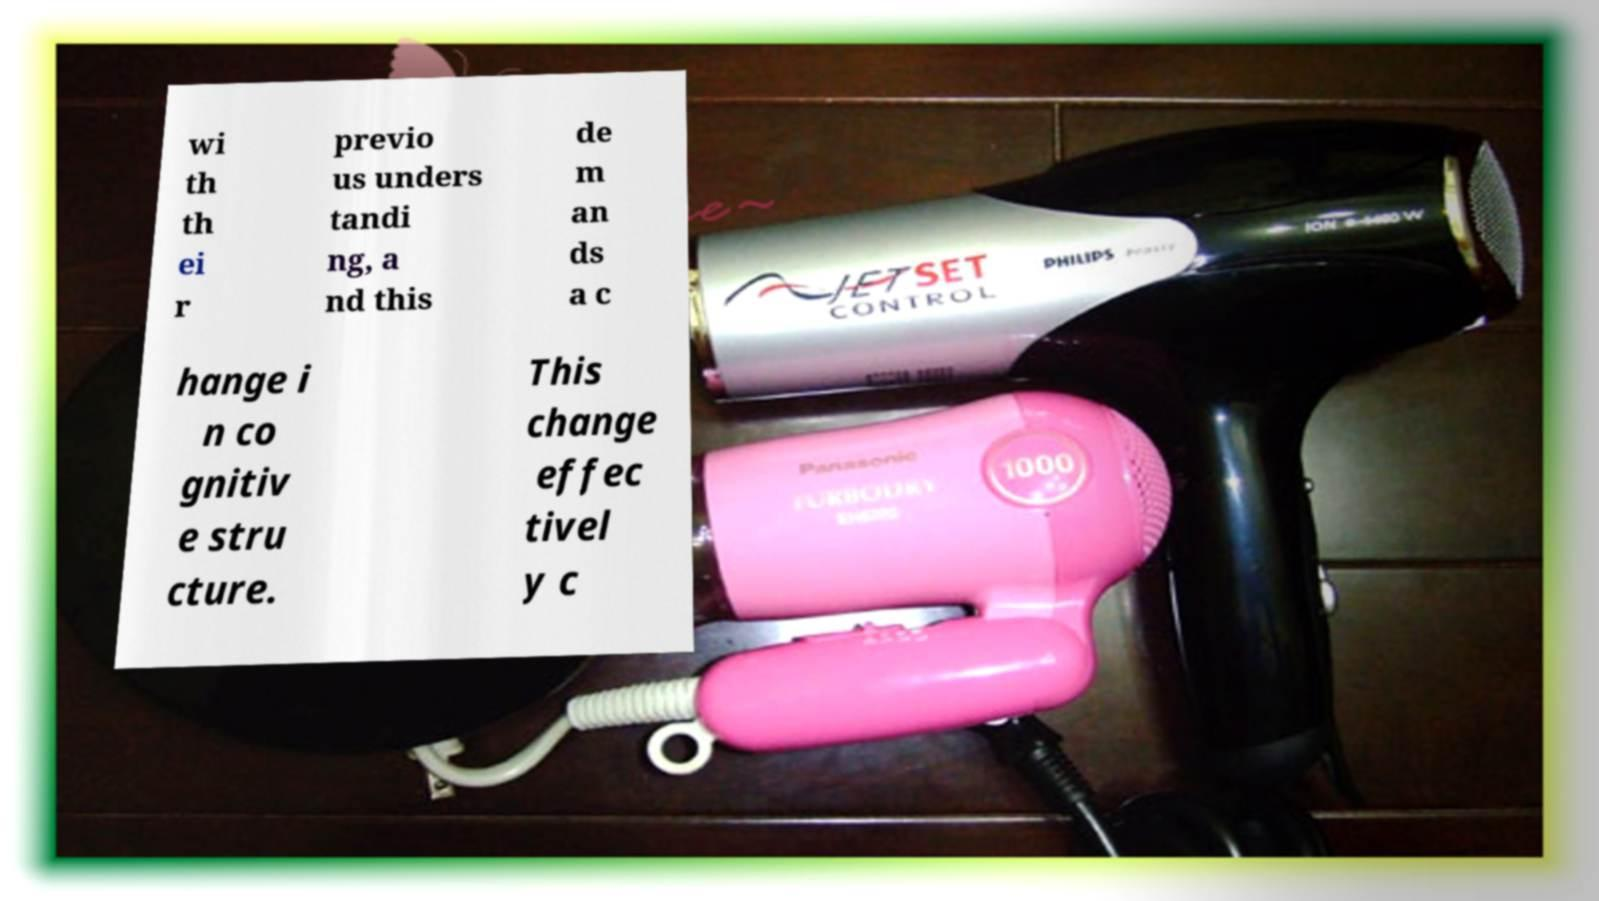Please read and relay the text visible in this image. What does it say? wi th th ei r previo us unders tandi ng, a nd this de m an ds a c hange i n co gnitiv e stru cture. This change effec tivel y c 